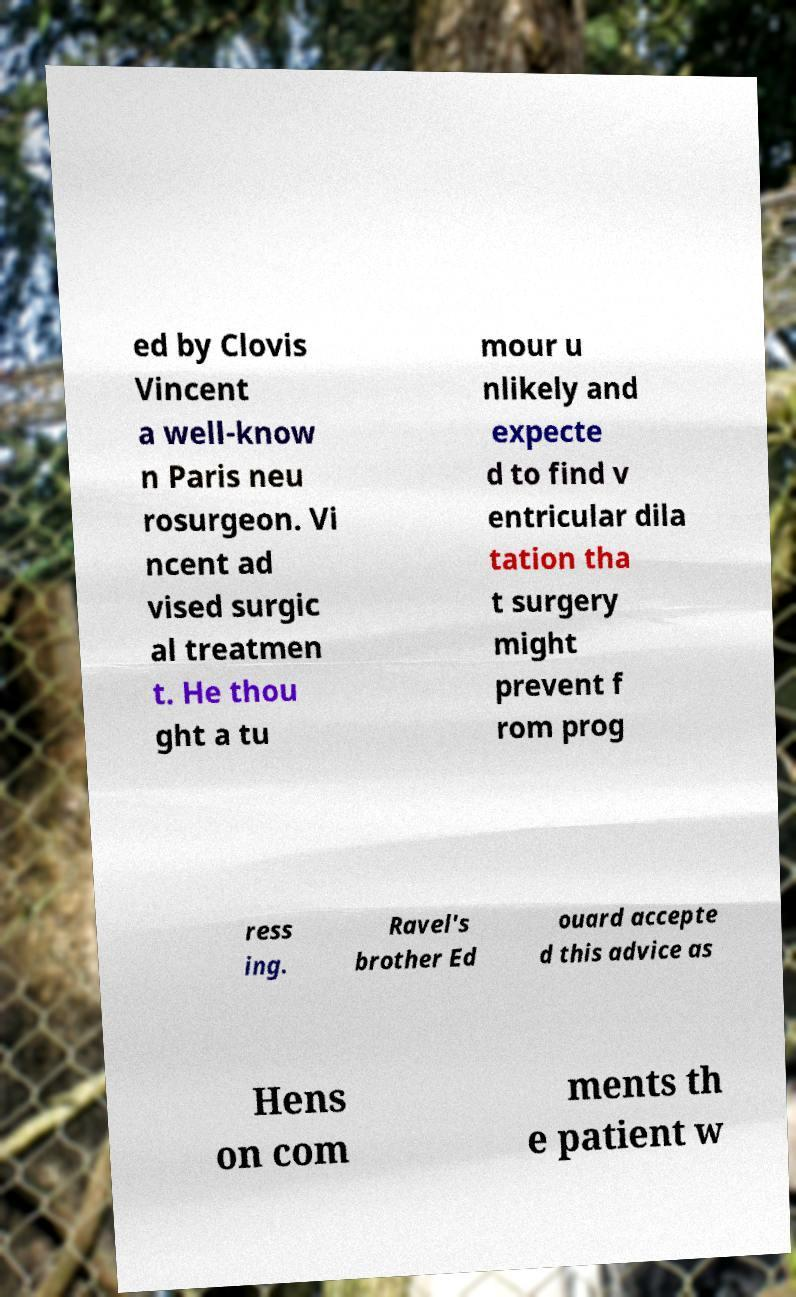Can you read and provide the text displayed in the image?This photo seems to have some interesting text. Can you extract and type it out for me? ed by Clovis Vincent a well-know n Paris neu rosurgeon. Vi ncent ad vised surgic al treatmen t. He thou ght a tu mour u nlikely and expecte d to find v entricular dila tation tha t surgery might prevent f rom prog ress ing. Ravel's brother Ed ouard accepte d this advice as Hens on com ments th e patient w 